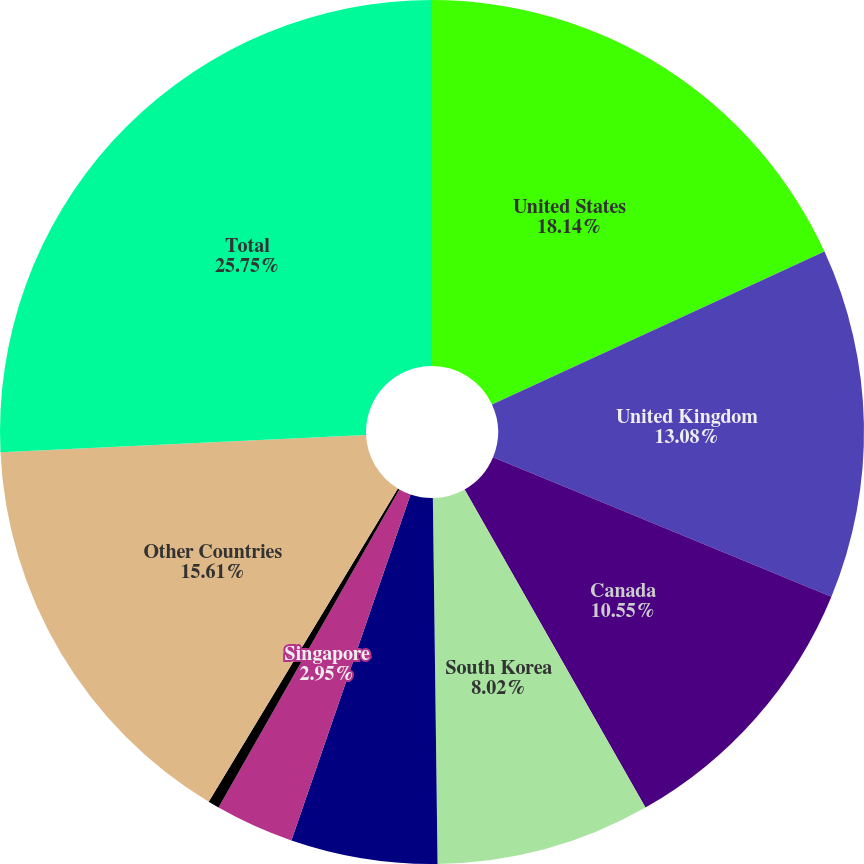Convert chart to OTSL. <chart><loc_0><loc_0><loc_500><loc_500><pie_chart><fcel>United States<fcel>United Kingdom<fcel>Canada<fcel>South Korea<fcel>Brazil<fcel>Singapore<fcel>Norway<fcel>Other Countries<fcel>Total<nl><fcel>18.14%<fcel>13.08%<fcel>10.55%<fcel>8.02%<fcel>5.48%<fcel>2.95%<fcel>0.42%<fcel>15.61%<fcel>25.74%<nl></chart> 